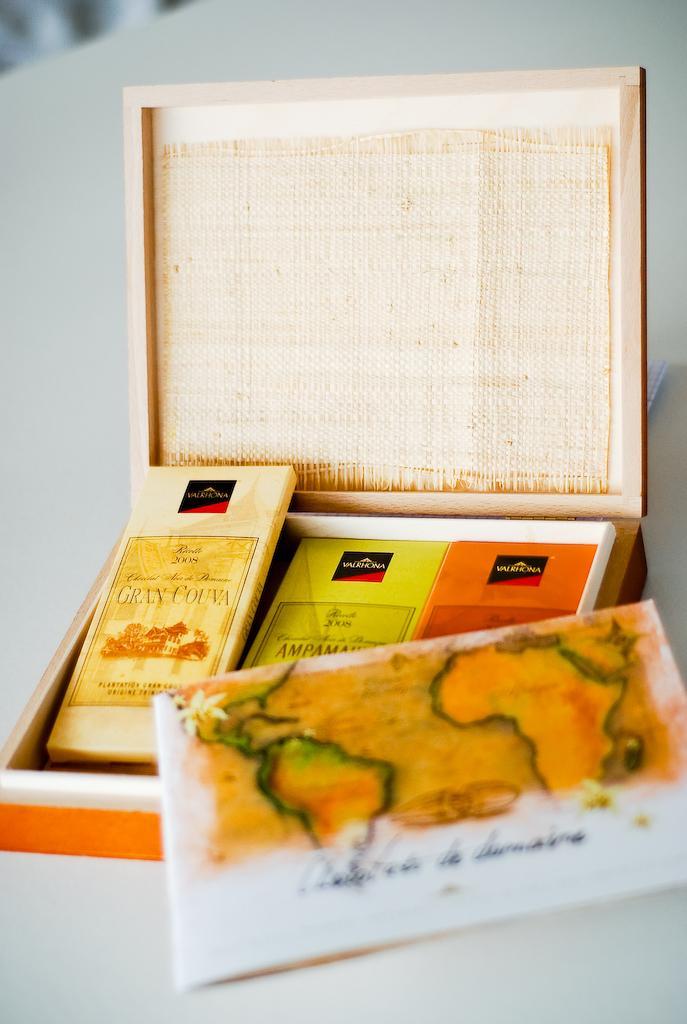Describe this image in one or two sentences. In this image, we can see some objects in the box and there is a paper with some text. At the bottom, there is a table. 